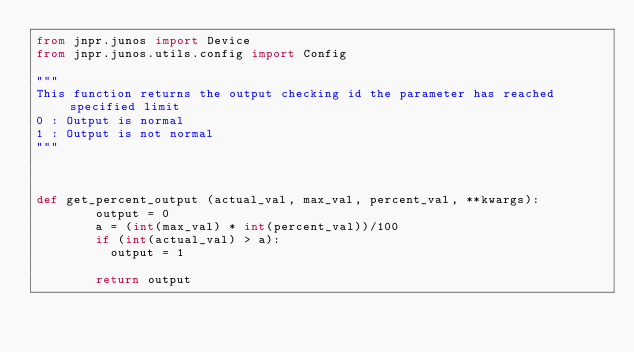Convert code to text. <code><loc_0><loc_0><loc_500><loc_500><_Python_>from jnpr.junos import Device
from jnpr.junos.utils.config import Config

"""
This function returns the output checking id the parameter has reached specified limit
0 : Output is normal
1 : Output is not normal
"""



def get_percent_output (actual_val, max_val, percent_val, **kwargs):
        output = 0
        a = (int(max_val) * int(percent_val))/100
        if (int(actual_val) > a):
          output = 1

        return output

</code> 